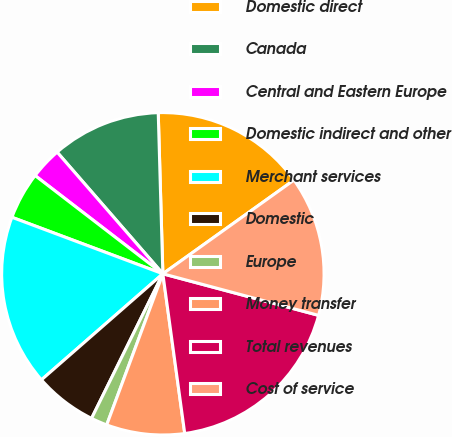<chart> <loc_0><loc_0><loc_500><loc_500><pie_chart><fcel>Domestic direct<fcel>Canada<fcel>Central and Eastern Europe<fcel>Domestic indirect and other<fcel>Merchant services<fcel>Domestic<fcel>Europe<fcel>Money transfer<fcel>Total revenues<fcel>Cost of service<nl><fcel>15.58%<fcel>10.93%<fcel>3.18%<fcel>4.73%<fcel>17.13%<fcel>6.28%<fcel>1.63%<fcel>7.83%<fcel>18.68%<fcel>14.03%<nl></chart> 